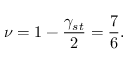Convert formula to latex. <formula><loc_0><loc_0><loc_500><loc_500>\nu = 1 - \frac { \gamma _ { s t } } { 2 } = \frac { 7 } { 6 } .</formula> 